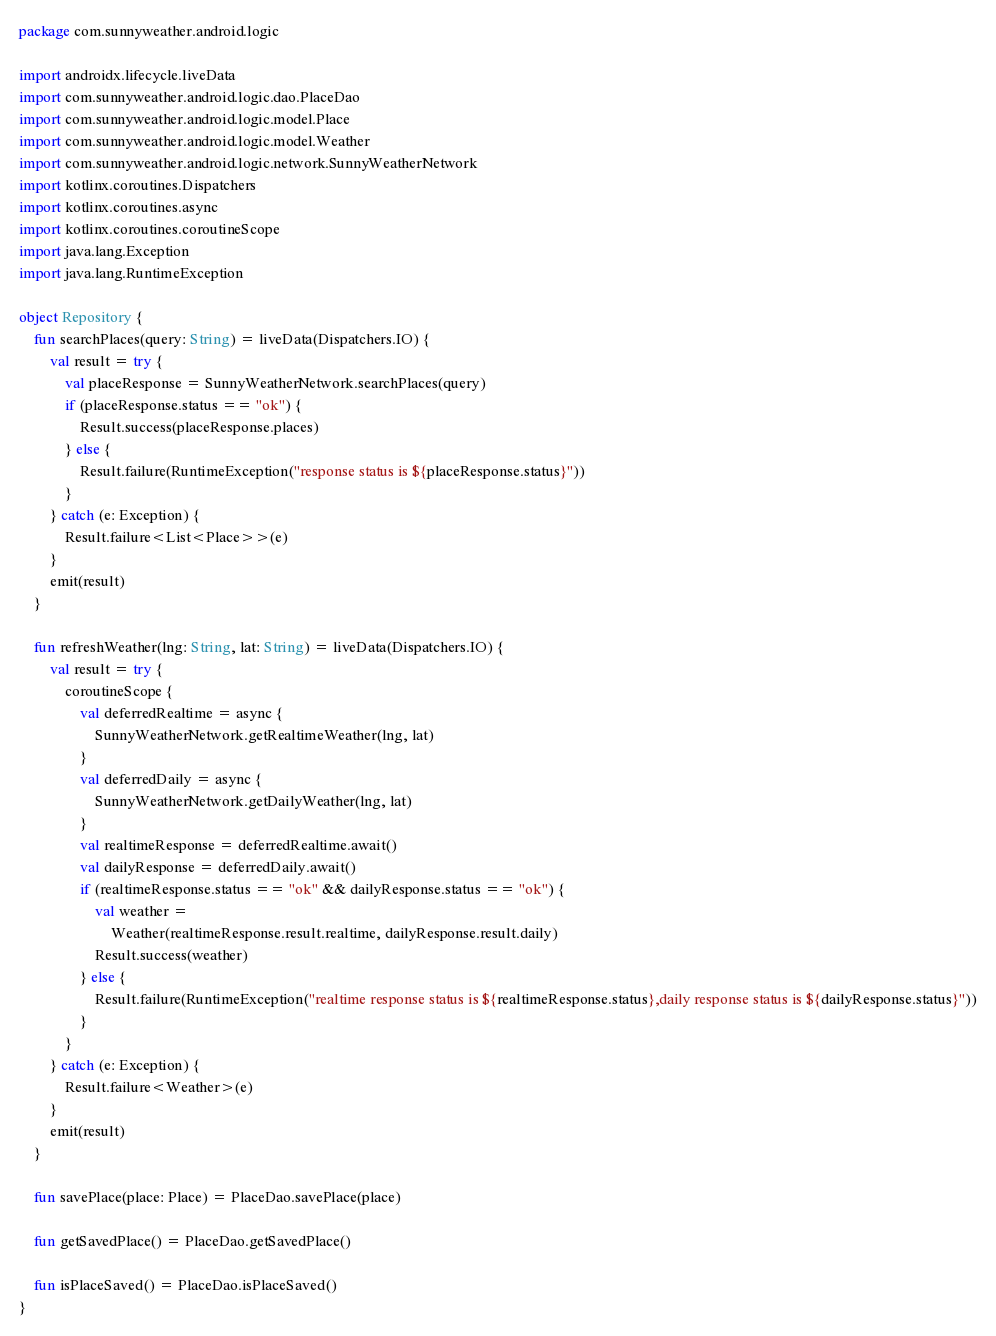Convert code to text. <code><loc_0><loc_0><loc_500><loc_500><_Kotlin_>package com.sunnyweather.android.logic

import androidx.lifecycle.liveData
import com.sunnyweather.android.logic.dao.PlaceDao
import com.sunnyweather.android.logic.model.Place
import com.sunnyweather.android.logic.model.Weather
import com.sunnyweather.android.logic.network.SunnyWeatherNetwork
import kotlinx.coroutines.Dispatchers
import kotlinx.coroutines.async
import kotlinx.coroutines.coroutineScope
import java.lang.Exception
import java.lang.RuntimeException

object Repository {
    fun searchPlaces(query: String) = liveData(Dispatchers.IO) {
        val result = try {
            val placeResponse = SunnyWeatherNetwork.searchPlaces(query)
            if (placeResponse.status == "ok") {
                Result.success(placeResponse.places)
            } else {
                Result.failure(RuntimeException("response status is ${placeResponse.status}"))
            }
        } catch (e: Exception) {
            Result.failure<List<Place>>(e)
        }
        emit(result)
    }

    fun refreshWeather(lng: String, lat: String) = liveData(Dispatchers.IO) {
        val result = try {
            coroutineScope {
                val deferredRealtime = async {
                    SunnyWeatherNetwork.getRealtimeWeather(lng, lat)
                }
                val deferredDaily = async {
                    SunnyWeatherNetwork.getDailyWeather(lng, lat)
                }
                val realtimeResponse = deferredRealtime.await()
                val dailyResponse = deferredDaily.await()
                if (realtimeResponse.status == "ok" && dailyResponse.status == "ok") {
                    val weather =
                        Weather(realtimeResponse.result.realtime, dailyResponse.result.daily)
                    Result.success(weather)
                } else {
                    Result.failure(RuntimeException("realtime response status is ${realtimeResponse.status},daily response status is ${dailyResponse.status}"))
                }
            }
        } catch (e: Exception) {
            Result.failure<Weather>(e)
        }
        emit(result)
    }

    fun savePlace(place: Place) = PlaceDao.savePlace(place)

    fun getSavedPlace() = PlaceDao.getSavedPlace()

    fun isPlaceSaved() = PlaceDao.isPlaceSaved()
}</code> 